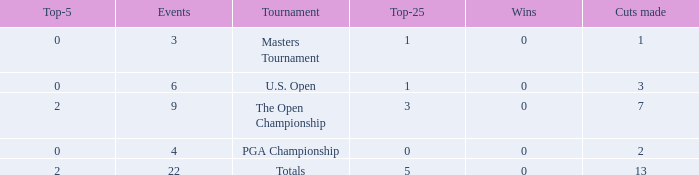What is the total number of wins for events with under 2 top-5s, under 5 top-25s, and more than 4 events played? 1.0. 